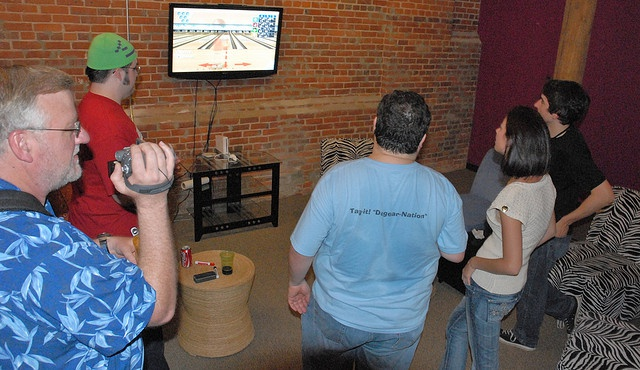Describe the objects in this image and their specific colors. I can see people in maroon, black, lightblue, gray, and blue tones, people in maroon, darkgray, gray, and black tones, couch in maroon, gray, and black tones, people in maroon, brown, green, and black tones, and people in maroon, black, brown, and gray tones in this image. 